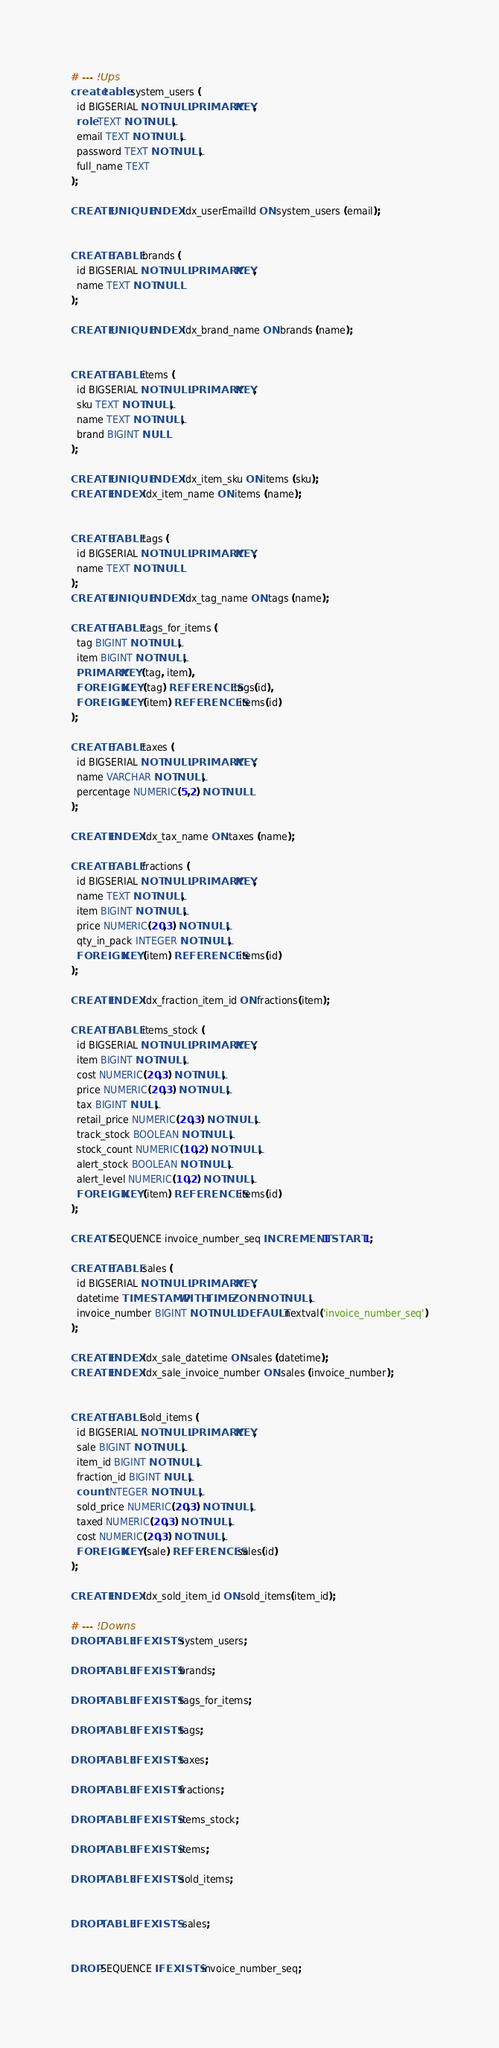Convert code to text. <code><loc_0><loc_0><loc_500><loc_500><_SQL_># --- !Ups
create table system_users (
  id BIGSERIAL NOT NULL PRIMARY KEY,
  role TEXT NOT NULL,
  email TEXT NOT NULL,
  password TEXT NOT NULL,
  full_name TEXT
);

CREATE UNIQUE INDEX idx_userEmailId ON system_users (email);


CREATE TABLE brands (
  id BIGSERIAL NOT NULL PRIMARY KEY,
  name TEXT NOT NULL
);

CREATE UNIQUE INDEX idx_brand_name ON brands (name);


CREATE TABLE items (
  id BIGSERIAL NOT NULL PRIMARY KEY,
  sku TEXT NOT NULL,
  name TEXT NOT NULL,
  brand BIGINT NULL
);

CREATE UNIQUE INDEX idx_item_sku ON items (sku);
CREATE INDEX idx_item_name ON items (name);


CREATE TABLE tags (
  id BIGSERIAL NOT NULL PRIMARY KEY,
  name TEXT NOT NULL
);
CREATE UNIQUE INDEX idx_tag_name ON tags (name);

CREATE TABLE tags_for_items (
  tag BIGINT NOT NULL,
  item BIGINT NOT NULL,
  PRIMARY KEY (tag, item),
  FOREIGN KEY (tag) REFERENCES tags(id),
  FOREIGN KEY (item) REFERENCES items(id)
);

CREATE TABLE taxes (
  id BIGSERIAL NOT NULL PRIMARY KEY,
  name VARCHAR NOT NULL,
  percentage NUMERIC(5,2) NOT NULL
);

CREATE INDEX idx_tax_name ON taxes (name);

CREATE TABLE fractions (
  id BIGSERIAL NOT NULL PRIMARY KEY,
  name TEXT NOT NULL,
  item BIGINT NOT NULL,
  price NUMERIC(20,3) NOT NULL,
  qty_in_pack INTEGER NOT NULL,
  FOREIGN KEY (item) REFERENCES items(id)
);

CREATE INDEX idx_fraction_item_id ON fractions(item);

CREATE TABLE items_stock (
  id BIGSERIAL NOT NULL PRIMARY KEY,
  item BIGINT NOT NULL,
  cost NUMERIC(20,3) NOT NULL,
  price NUMERIC(20,3) NOT NULL,
  tax BIGINT NULL,
  retail_price NUMERIC(20,3) NOT NULL,
  track_stock BOOLEAN NOT NULL,
  stock_count NUMERIC(10,2) NOT NULL,
  alert_stock BOOLEAN NOT NULL,
  alert_level NUMERIC(10,2) NOT NULL,
  FOREIGN KEY (item) REFERENCES items(id)
);

CREATE SEQUENCE invoice_number_seq INCREMENT 1 START 1;

CREATE TABLE sales (
  id BIGSERIAL NOT NULL PRIMARY KEY,
  datetime TIMESTAMP WITH TIME ZONE NOT NULL,
  invoice_number BIGINT NOT NULL DEFAULT nextval('invoice_number_seq')
);

CREATE INDEX idx_sale_datetime ON sales (datetime);
CREATE INDEX idx_sale_invoice_number ON sales (invoice_number);


CREATE TABLE sold_items (
  id BIGSERIAL NOT NULL PRIMARY KEY,
  sale BIGINT NOT NULL,
  item_id BIGINT NOT NULL,
  fraction_id BIGINT NULL,
  count INTEGER NOT NULL,
  sold_price NUMERIC(20,3) NOT NULL,
  taxed NUMERIC(20,3) NOT NULL,
  cost NUMERIC(20,3) NOT NULL,
  FOREIGN KEY (sale) REFERENCES sales(id)
);

CREATE INDEX idx_sold_item_id ON sold_items(item_id);

# --- !Downs
DROP TABLE IF EXISTS system_users;

DROP TABLE IF EXISTS brands;

DROP TABLE IF EXISTS tags_for_items;

DROP TABLE IF EXISTS tags;

DROP TABLE IF EXISTS taxes;

DROP TABLE IF EXISTS fractions;

DROP TABLE IF EXISTS items_stock;

DROP TABLE IF EXISTS items;

DROP TABLE IF EXISTS sold_items;


DROP TABLE IF EXISTS  sales;


DROP SEQUENCE IF EXISTS invoice_number_seq;

</code> 